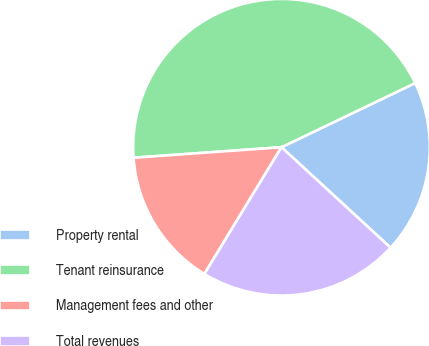Convert chart to OTSL. <chart><loc_0><loc_0><loc_500><loc_500><pie_chart><fcel>Property rental<fcel>Tenant reinsurance<fcel>Management fees and other<fcel>Total revenues<nl><fcel>18.97%<fcel>44.01%<fcel>15.17%<fcel>21.85%<nl></chart> 